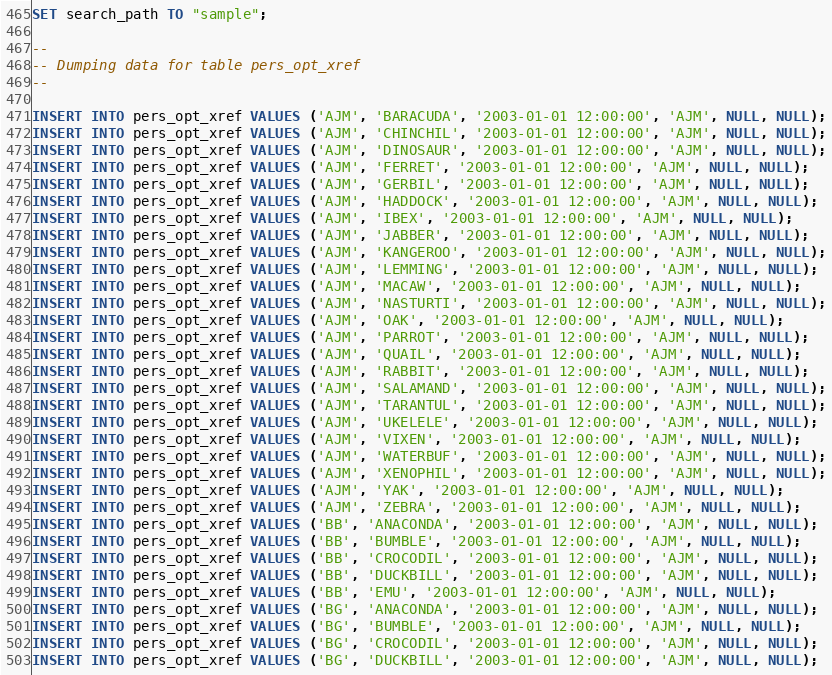<code> <loc_0><loc_0><loc_500><loc_500><_SQL_>SET search_path TO "sample";

-- 
-- Dumping data for table pers_opt_xref
-- 

INSERT INTO pers_opt_xref VALUES ('AJM', 'BARACUDA', '2003-01-01 12:00:00', 'AJM', NULL, NULL);
INSERT INTO pers_opt_xref VALUES ('AJM', 'CHINCHIL', '2003-01-01 12:00:00', 'AJM', NULL, NULL);
INSERT INTO pers_opt_xref VALUES ('AJM', 'DINOSAUR', '2003-01-01 12:00:00', 'AJM', NULL, NULL);
INSERT INTO pers_opt_xref VALUES ('AJM', 'FERRET', '2003-01-01 12:00:00', 'AJM', NULL, NULL);
INSERT INTO pers_opt_xref VALUES ('AJM', 'GERBIL', '2003-01-01 12:00:00', 'AJM', NULL, NULL);
INSERT INTO pers_opt_xref VALUES ('AJM', 'HADDOCK', '2003-01-01 12:00:00', 'AJM', NULL, NULL);
INSERT INTO pers_opt_xref VALUES ('AJM', 'IBEX', '2003-01-01 12:00:00', 'AJM', NULL, NULL);
INSERT INTO pers_opt_xref VALUES ('AJM', 'JABBER', '2003-01-01 12:00:00', 'AJM', NULL, NULL);
INSERT INTO pers_opt_xref VALUES ('AJM', 'KANGEROO', '2003-01-01 12:00:00', 'AJM', NULL, NULL);
INSERT INTO pers_opt_xref VALUES ('AJM', 'LEMMING', '2003-01-01 12:00:00', 'AJM', NULL, NULL);
INSERT INTO pers_opt_xref VALUES ('AJM', 'MACAW', '2003-01-01 12:00:00', 'AJM', NULL, NULL);
INSERT INTO pers_opt_xref VALUES ('AJM', 'NASTURTI', '2003-01-01 12:00:00', 'AJM', NULL, NULL);
INSERT INTO pers_opt_xref VALUES ('AJM', 'OAK', '2003-01-01 12:00:00', 'AJM', NULL, NULL);
INSERT INTO pers_opt_xref VALUES ('AJM', 'PARROT', '2003-01-01 12:00:00', 'AJM', NULL, NULL);
INSERT INTO pers_opt_xref VALUES ('AJM', 'QUAIL', '2003-01-01 12:00:00', 'AJM', NULL, NULL);
INSERT INTO pers_opt_xref VALUES ('AJM', 'RABBIT', '2003-01-01 12:00:00', 'AJM', NULL, NULL);
INSERT INTO pers_opt_xref VALUES ('AJM', 'SALAMAND', '2003-01-01 12:00:00', 'AJM', NULL, NULL);
INSERT INTO pers_opt_xref VALUES ('AJM', 'TARANTUL', '2003-01-01 12:00:00', 'AJM', NULL, NULL);
INSERT INTO pers_opt_xref VALUES ('AJM', 'UKELELE', '2003-01-01 12:00:00', 'AJM', NULL, NULL);
INSERT INTO pers_opt_xref VALUES ('AJM', 'VIXEN', '2003-01-01 12:00:00', 'AJM', NULL, NULL);
INSERT INTO pers_opt_xref VALUES ('AJM', 'WATERBUF', '2003-01-01 12:00:00', 'AJM', NULL, NULL);
INSERT INTO pers_opt_xref VALUES ('AJM', 'XENOPHIL', '2003-01-01 12:00:00', 'AJM', NULL, NULL);
INSERT INTO pers_opt_xref VALUES ('AJM', 'YAK', '2003-01-01 12:00:00', 'AJM', NULL, NULL);
INSERT INTO pers_opt_xref VALUES ('AJM', 'ZEBRA', '2003-01-01 12:00:00', 'AJM', NULL, NULL);
INSERT INTO pers_opt_xref VALUES ('BB', 'ANACONDA', '2003-01-01 12:00:00', 'AJM', NULL, NULL);
INSERT INTO pers_opt_xref VALUES ('BB', 'BUMBLE', '2003-01-01 12:00:00', 'AJM', NULL, NULL);
INSERT INTO pers_opt_xref VALUES ('BB', 'CROCODIL', '2003-01-01 12:00:00', 'AJM', NULL, NULL);
INSERT INTO pers_opt_xref VALUES ('BB', 'DUCKBILL', '2003-01-01 12:00:00', 'AJM', NULL, NULL);
INSERT INTO pers_opt_xref VALUES ('BB', 'EMU', '2003-01-01 12:00:00', 'AJM', NULL, NULL);
INSERT INTO pers_opt_xref VALUES ('BG', 'ANACONDA', '2003-01-01 12:00:00', 'AJM', NULL, NULL);
INSERT INTO pers_opt_xref VALUES ('BG', 'BUMBLE', '2003-01-01 12:00:00', 'AJM', NULL, NULL);
INSERT INTO pers_opt_xref VALUES ('BG', 'CROCODIL', '2003-01-01 12:00:00', 'AJM', NULL, NULL);
INSERT INTO pers_opt_xref VALUES ('BG', 'DUCKBILL', '2003-01-01 12:00:00', 'AJM', NULL, NULL);</code> 